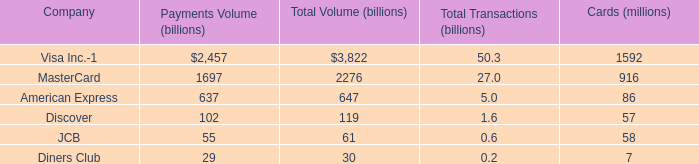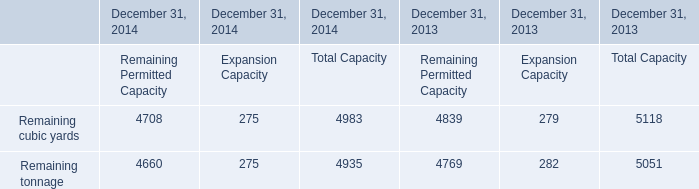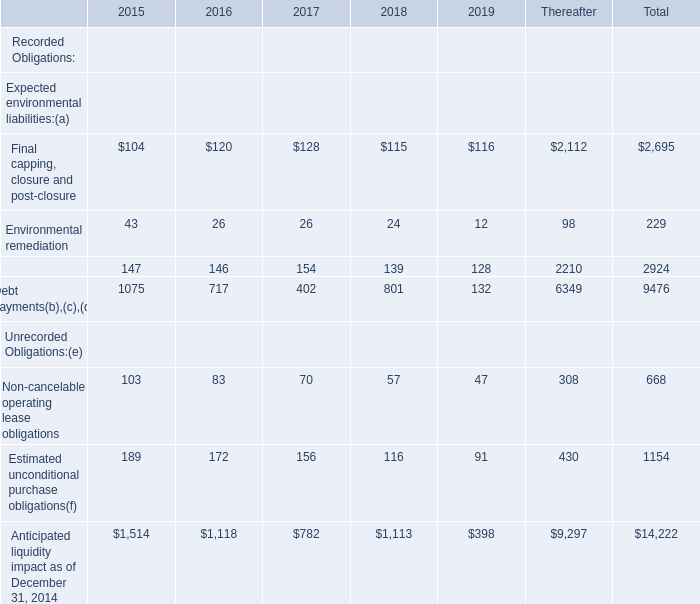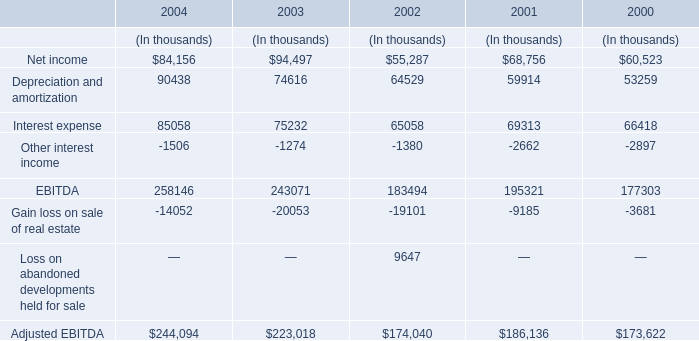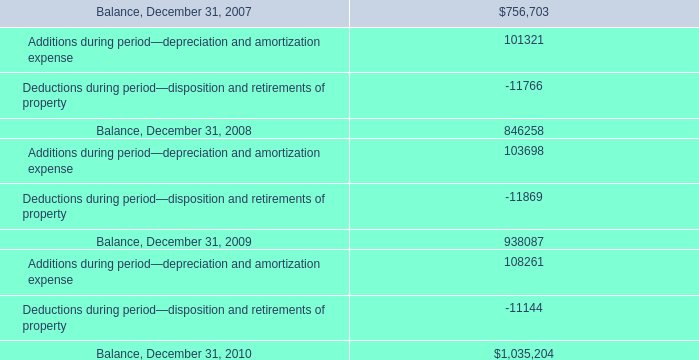Among 2017,2018 and 2019,for which year is Anticipated liquidity impact as of December 31, 2014 the least? 
Answer: 2019. 